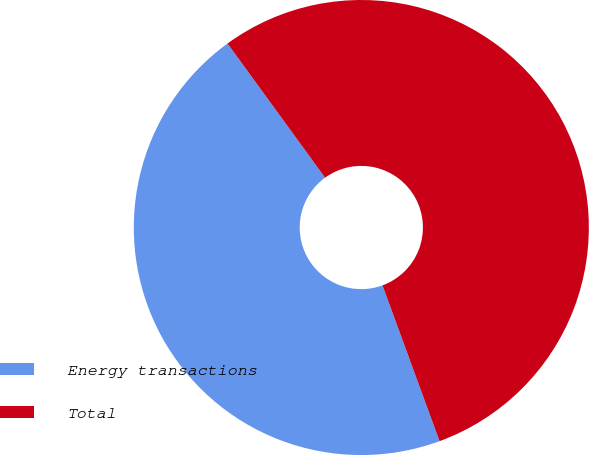Convert chart. <chart><loc_0><loc_0><loc_500><loc_500><pie_chart><fcel>Energy transactions<fcel>Total<nl><fcel>45.58%<fcel>54.42%<nl></chart> 